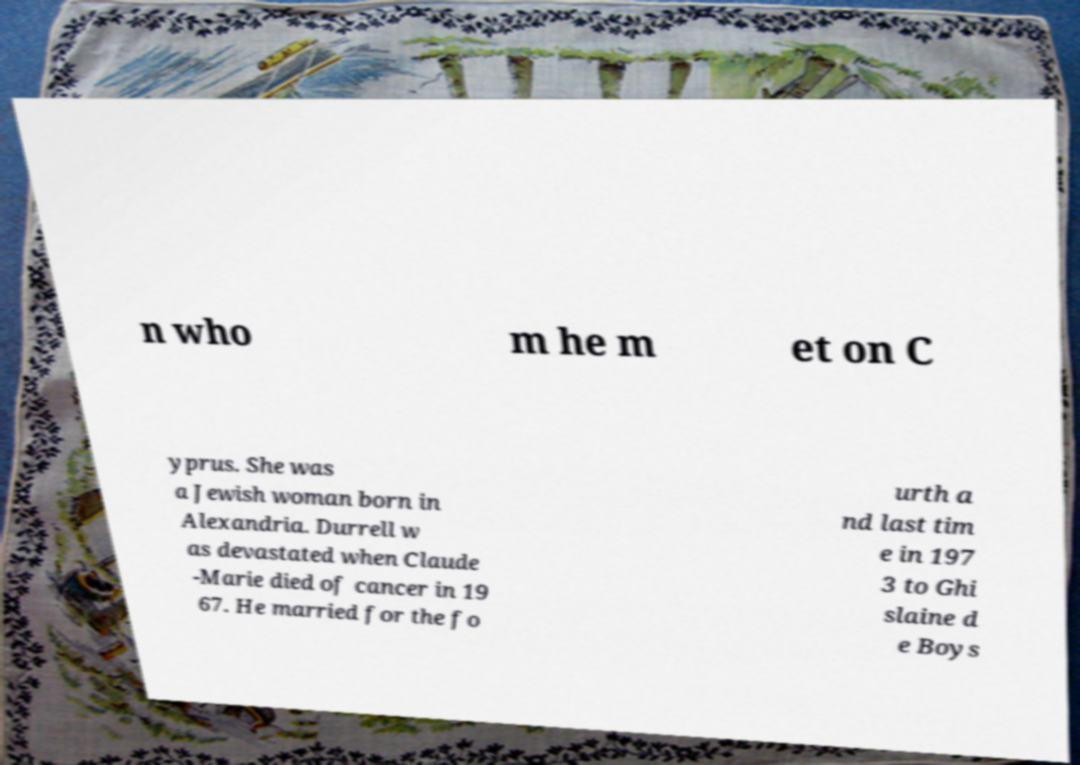There's text embedded in this image that I need extracted. Can you transcribe it verbatim? n who m he m et on C yprus. She was a Jewish woman born in Alexandria. Durrell w as devastated when Claude -Marie died of cancer in 19 67. He married for the fo urth a nd last tim e in 197 3 to Ghi slaine d e Boys 